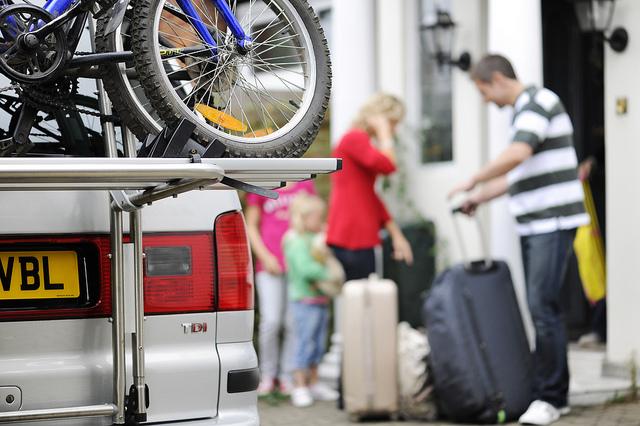Is this in the United States?
Short answer required. No. What color are the stripes on the man's shirt?
Write a very short answer. Black. How many roller suitcases do you see?
Keep it brief. 2. 